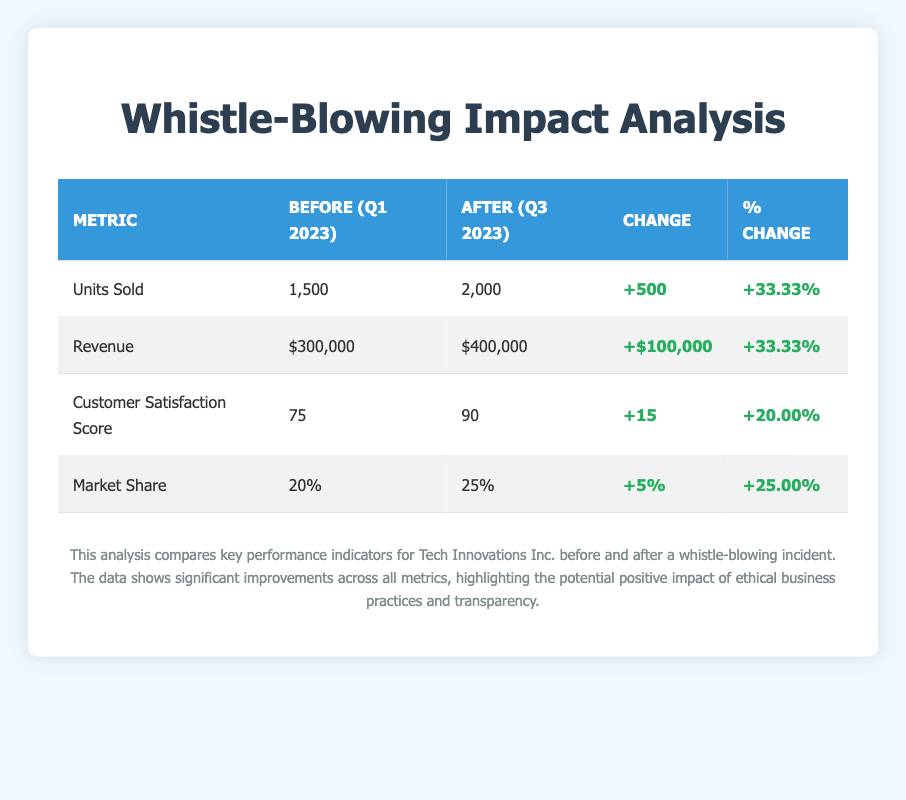What were the units sold before the whistle-blowing incident? The table indicates that units sold before the whistle-blowing incident were 1,500.
Answer: 1,500 What was the customer satisfaction score after the whistle-blowing incident? According to the table, the customer satisfaction score after the whistle-blowing incident was 90.
Answer: 90 Was there an increase in revenue after the whistle-blowing incident? The table shows that revenue after the whistle-blowing incident was $400,000, which is higher than the pre-incident revenue of $300,000, confirming an increase.
Answer: Yes What was the percentage change in market share after the whistle-blowing incident? The market share before was 20% and after was 25%; thus the percentage change is calculated by (25 - 20) / 20 * 100 = 25%.
Answer: 25.00% If 2,000 units were sold after the incident, how many total units were sold before and after? The total units sold is the sum of units sold before (1,500) and after (2,000). Therefore, the total is 1,500 + 2,000 = 3,500.
Answer: 3,500 What is the difference in customer satisfaction score before and after? The customer satisfaction score before was 75 and after it was 90; thus, the difference is calculated as 90 - 75 = 15.
Answer: 15 Did the company’s market share decrease after the whistle-blowing incident? The table indicates that the market share increased from 20% to 25%, hence it did not decrease.
Answer: No How does the revenue change compare to the change in units sold? The revenue increased by $100,000, while the units sold increased by 500. The revenue percentage change is the same as the units sold percentage change (both are 33.33%), which indicates a proportional relationship.
Answer: They are the same percentage change 